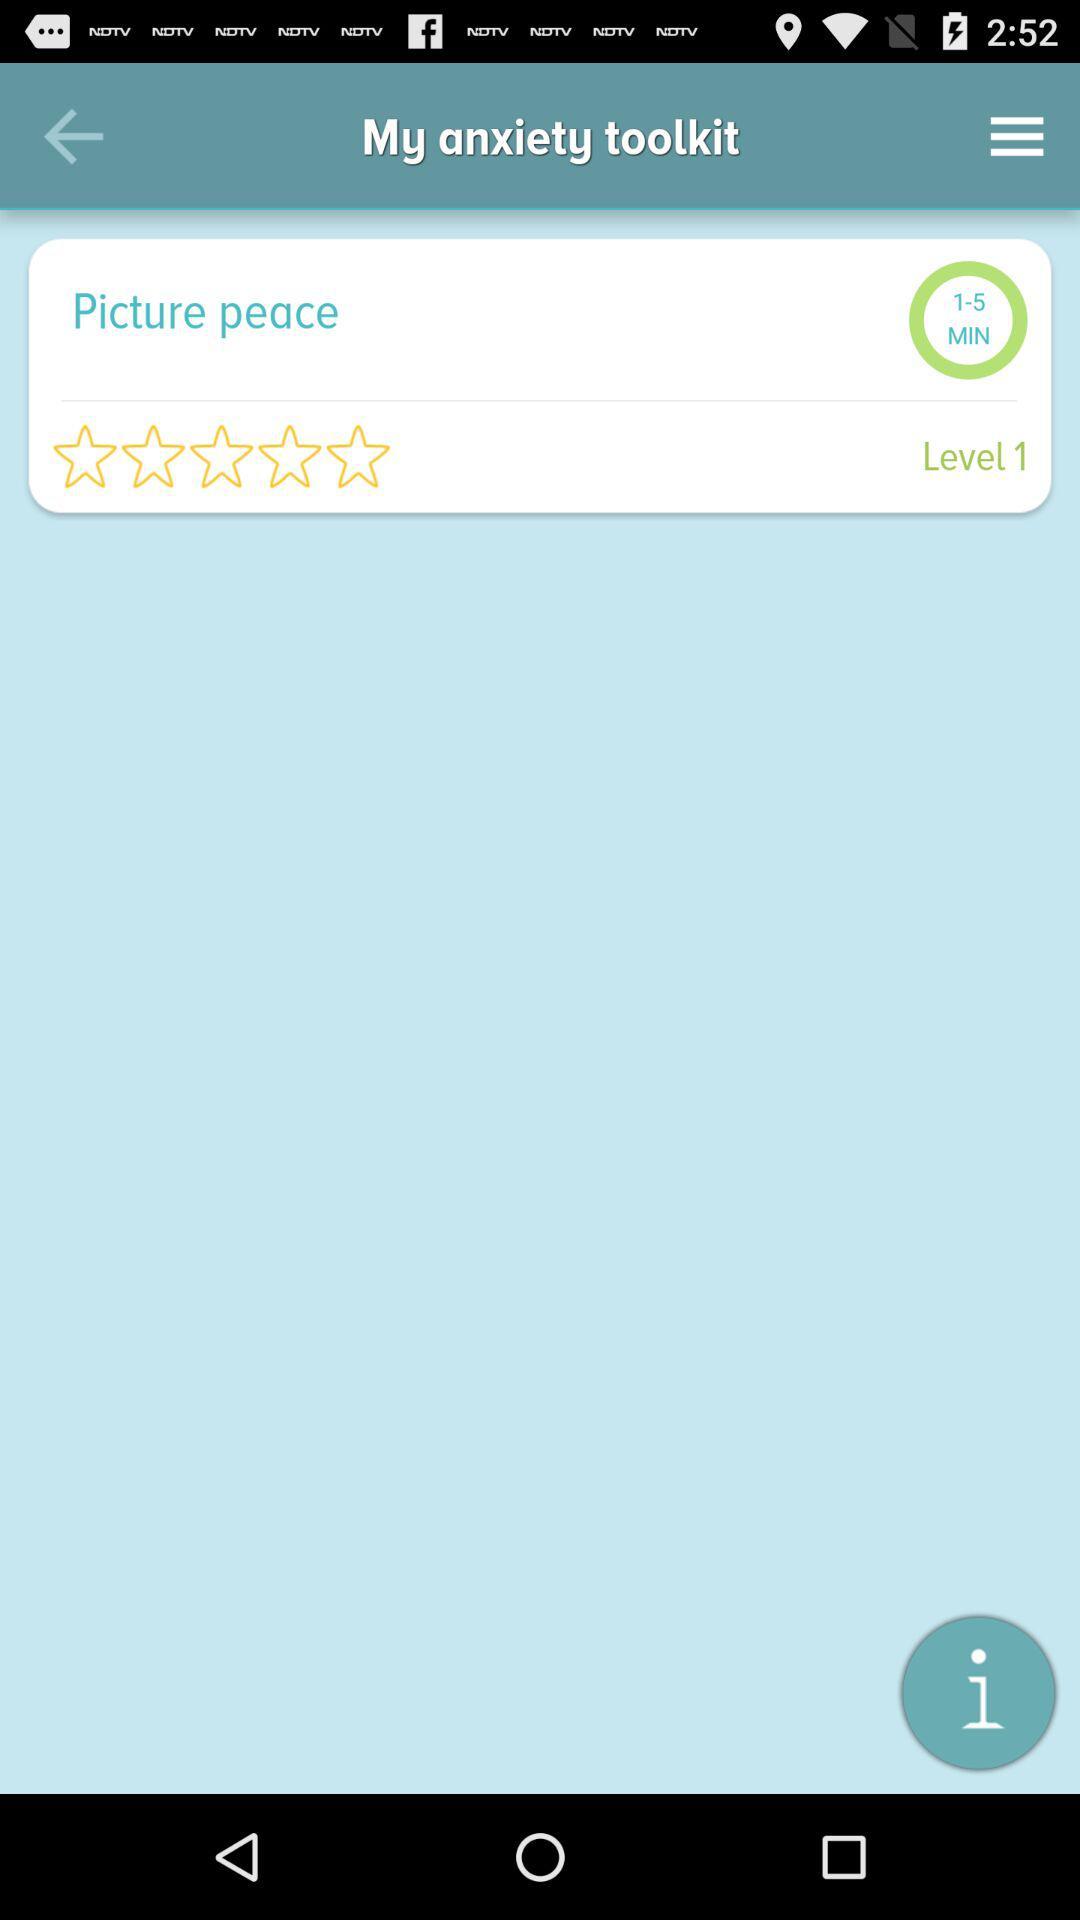What is the level? The level is 1. 